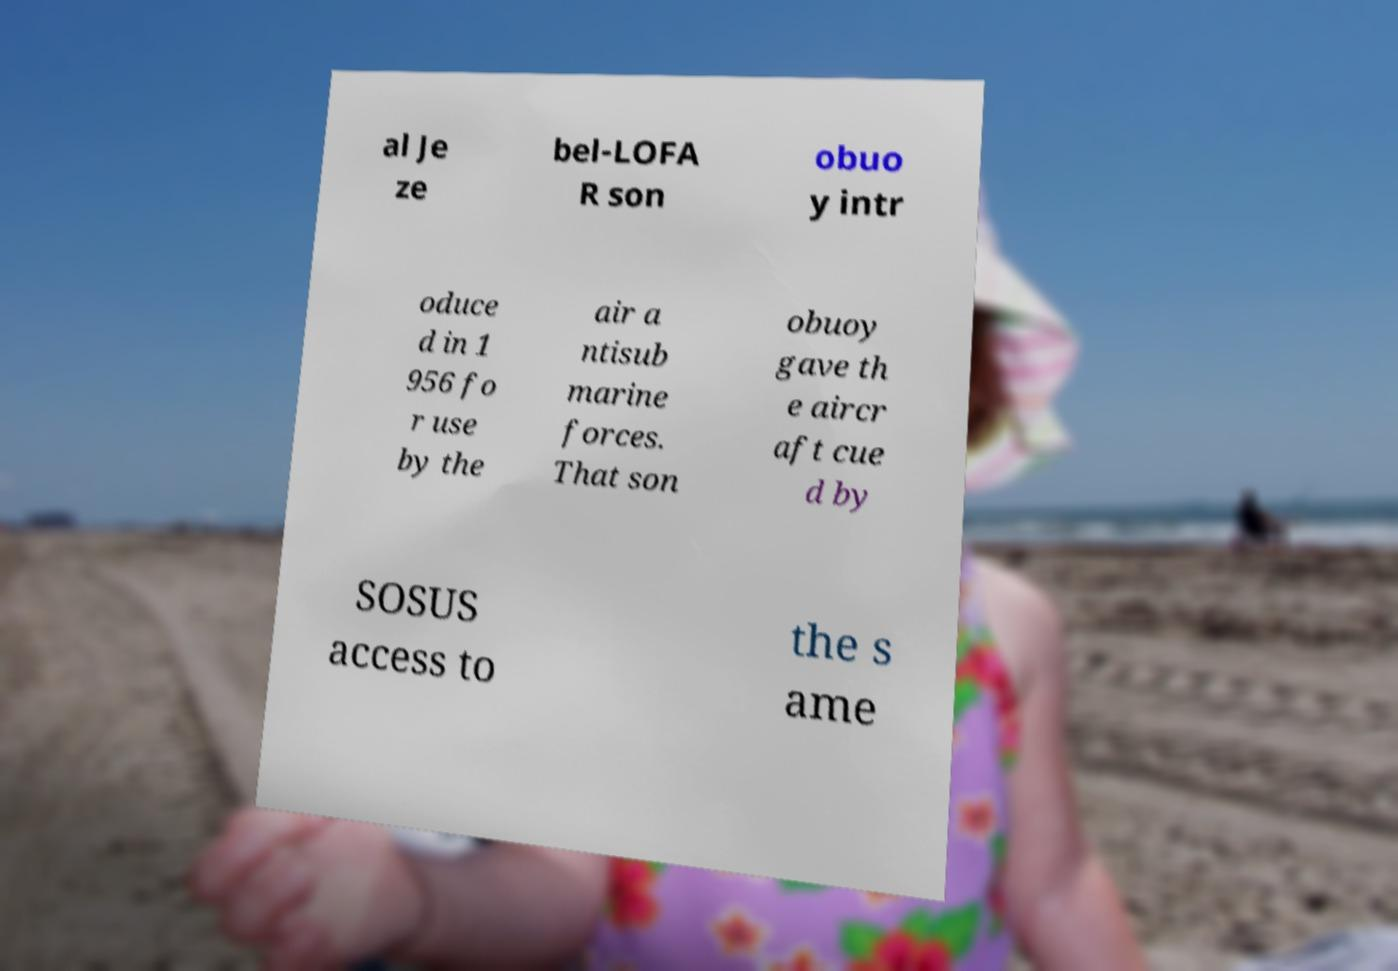For documentation purposes, I need the text within this image transcribed. Could you provide that? al Je ze bel-LOFA R son obuo y intr oduce d in 1 956 fo r use by the air a ntisub marine forces. That son obuoy gave th e aircr aft cue d by SOSUS access to the s ame 